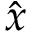<formula> <loc_0><loc_0><loc_500><loc_500>\hat { x }</formula> 